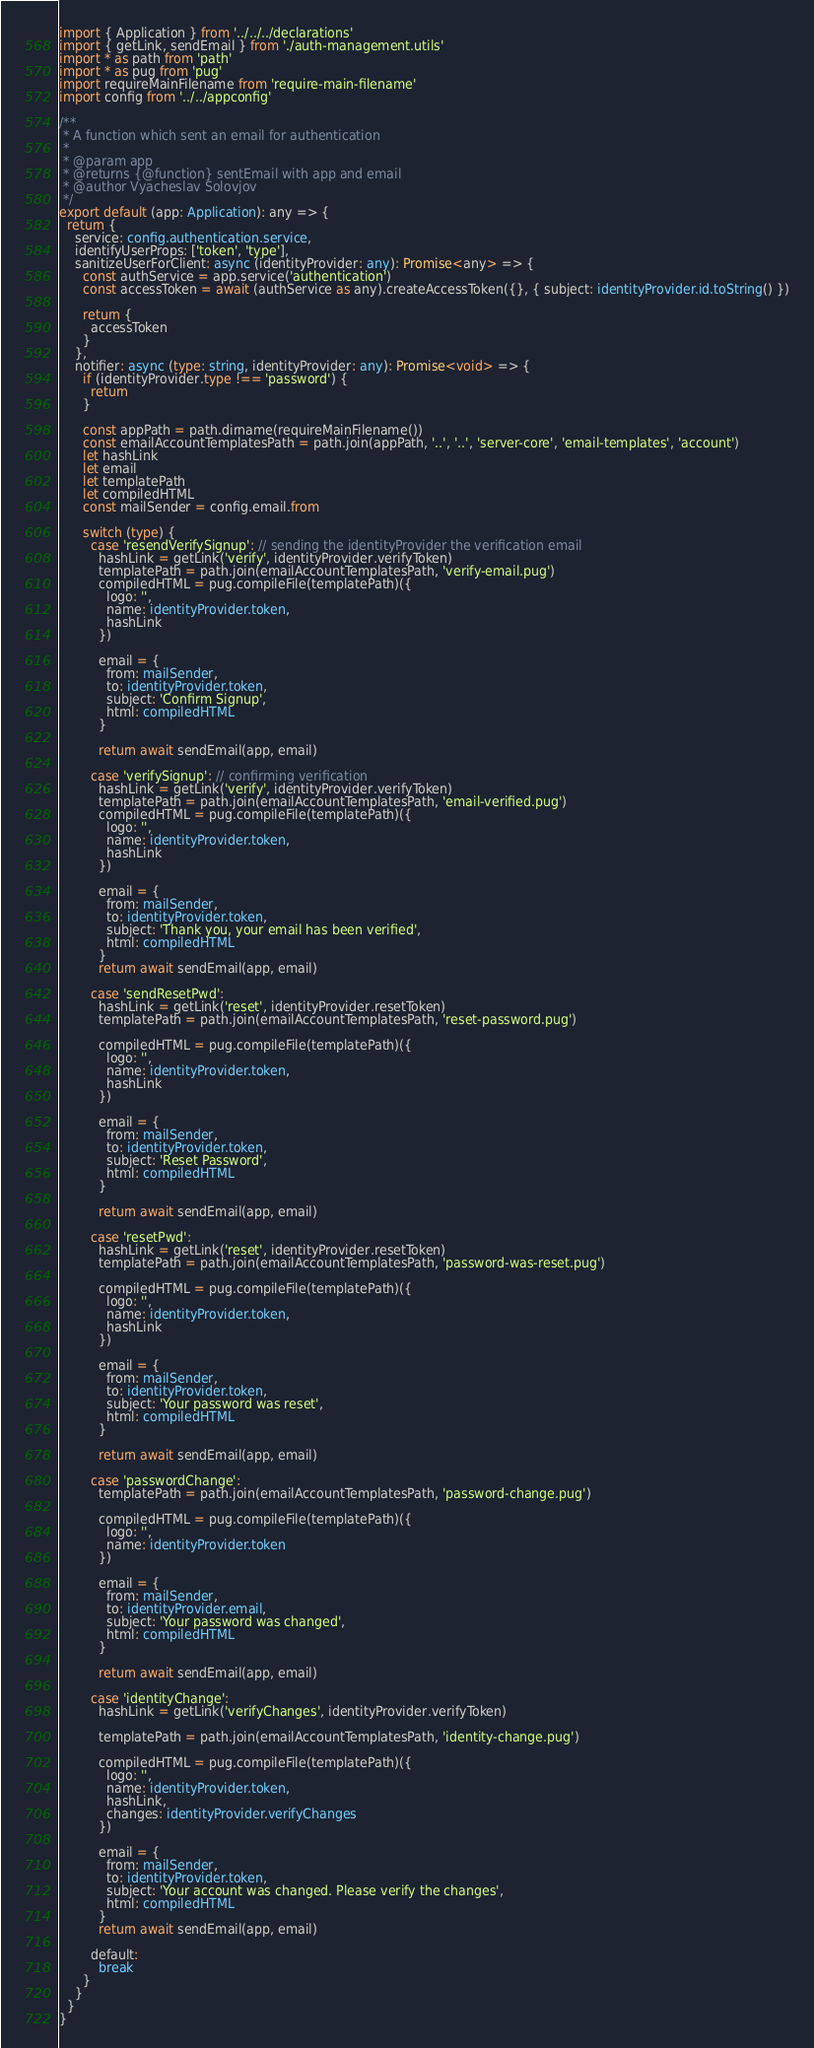<code> <loc_0><loc_0><loc_500><loc_500><_TypeScript_>import { Application } from '../../../declarations'
import { getLink, sendEmail } from './auth-management.utils'
import * as path from 'path'
import * as pug from 'pug'
import requireMainFilename from 'require-main-filename'
import config from '../../appconfig'

/**
 * A function which sent an email for authentication
 *
 * @param app
 * @returns {@function} sentEmail with app and email
 * @author Vyacheslav Solovjov
 */
export default (app: Application): any => {
  return {
    service: config.authentication.service,
    identifyUserProps: ['token', 'type'],
    sanitizeUserForClient: async (identityProvider: any): Promise<any> => {
      const authService = app.service('authentication')
      const accessToken = await (authService as any).createAccessToken({}, { subject: identityProvider.id.toString() })

      return {
        accessToken
      }
    },
    notifier: async (type: string, identityProvider: any): Promise<void> => {
      if (identityProvider.type !== 'password') {
        return
      }

      const appPath = path.dirname(requireMainFilename())
      const emailAccountTemplatesPath = path.join(appPath, '..', '..', 'server-core', 'email-templates', 'account')
      let hashLink
      let email
      let templatePath
      let compiledHTML
      const mailSender = config.email.from

      switch (type) {
        case 'resendVerifySignup': // sending the identityProvider the verification email
          hashLink = getLink('verify', identityProvider.verifyToken)
          templatePath = path.join(emailAccountTemplatesPath, 'verify-email.pug')
          compiledHTML = pug.compileFile(templatePath)({
            logo: '',
            name: identityProvider.token,
            hashLink
          })

          email = {
            from: mailSender,
            to: identityProvider.token,
            subject: 'Confirm Signup',
            html: compiledHTML
          }

          return await sendEmail(app, email)

        case 'verifySignup': // confirming verification
          hashLink = getLink('verify', identityProvider.verifyToken)
          templatePath = path.join(emailAccountTemplatesPath, 'email-verified.pug')
          compiledHTML = pug.compileFile(templatePath)({
            logo: '',
            name: identityProvider.token,
            hashLink
          })

          email = {
            from: mailSender,
            to: identityProvider.token,
            subject: 'Thank you, your email has been verified',
            html: compiledHTML
          }
          return await sendEmail(app, email)

        case 'sendResetPwd':
          hashLink = getLink('reset', identityProvider.resetToken)
          templatePath = path.join(emailAccountTemplatesPath, 'reset-password.pug')

          compiledHTML = pug.compileFile(templatePath)({
            logo: '',
            name: identityProvider.token,
            hashLink
          })

          email = {
            from: mailSender,
            to: identityProvider.token,
            subject: 'Reset Password',
            html: compiledHTML
          }

          return await sendEmail(app, email)

        case 'resetPwd':
          hashLink = getLink('reset', identityProvider.resetToken)
          templatePath = path.join(emailAccountTemplatesPath, 'password-was-reset.pug')

          compiledHTML = pug.compileFile(templatePath)({
            logo: '',
            name: identityProvider.token,
            hashLink
          })

          email = {
            from: mailSender,
            to: identityProvider.token,
            subject: 'Your password was reset',
            html: compiledHTML
          }

          return await sendEmail(app, email)

        case 'passwordChange':
          templatePath = path.join(emailAccountTemplatesPath, 'password-change.pug')

          compiledHTML = pug.compileFile(templatePath)({
            logo: '',
            name: identityProvider.token
          })

          email = {
            from: mailSender,
            to: identityProvider.email,
            subject: 'Your password was changed',
            html: compiledHTML
          }

          return await sendEmail(app, email)

        case 'identityChange':
          hashLink = getLink('verifyChanges', identityProvider.verifyToken)

          templatePath = path.join(emailAccountTemplatesPath, 'identity-change.pug')

          compiledHTML = pug.compileFile(templatePath)({
            logo: '',
            name: identityProvider.token,
            hashLink,
            changes: identityProvider.verifyChanges
          })

          email = {
            from: mailSender,
            to: identityProvider.token,
            subject: 'Your account was changed. Please verify the changes',
            html: compiledHTML
          }
          return await sendEmail(app, email)

        default:
          break
      }
    }
  }
}
</code> 